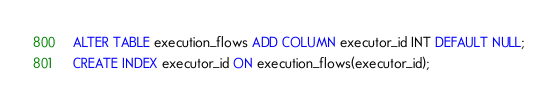<code> <loc_0><loc_0><loc_500><loc_500><_SQL_>ALTER TABLE execution_flows ADD COLUMN executor_id INT DEFAULT NULL;
CREATE INDEX executor_id ON execution_flows(executor_id);</code> 